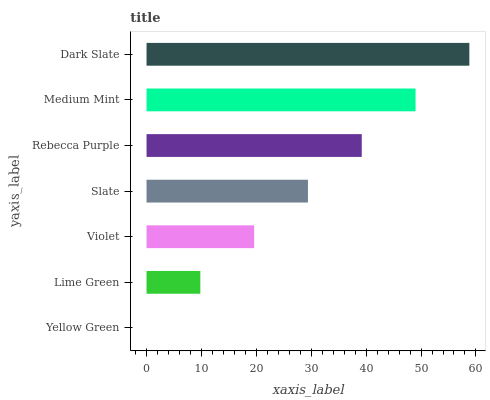Is Yellow Green the minimum?
Answer yes or no. Yes. Is Dark Slate the maximum?
Answer yes or no. Yes. Is Lime Green the minimum?
Answer yes or no. No. Is Lime Green the maximum?
Answer yes or no. No. Is Lime Green greater than Yellow Green?
Answer yes or no. Yes. Is Yellow Green less than Lime Green?
Answer yes or no. Yes. Is Yellow Green greater than Lime Green?
Answer yes or no. No. Is Lime Green less than Yellow Green?
Answer yes or no. No. Is Slate the high median?
Answer yes or no. Yes. Is Slate the low median?
Answer yes or no. Yes. Is Lime Green the high median?
Answer yes or no. No. Is Yellow Green the low median?
Answer yes or no. No. 